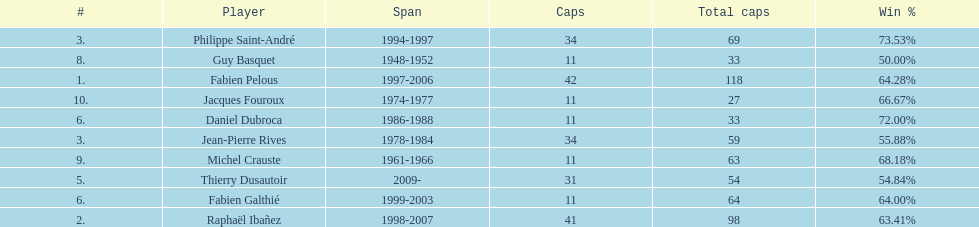Who had the largest win percentage? Philippe Saint-André. 